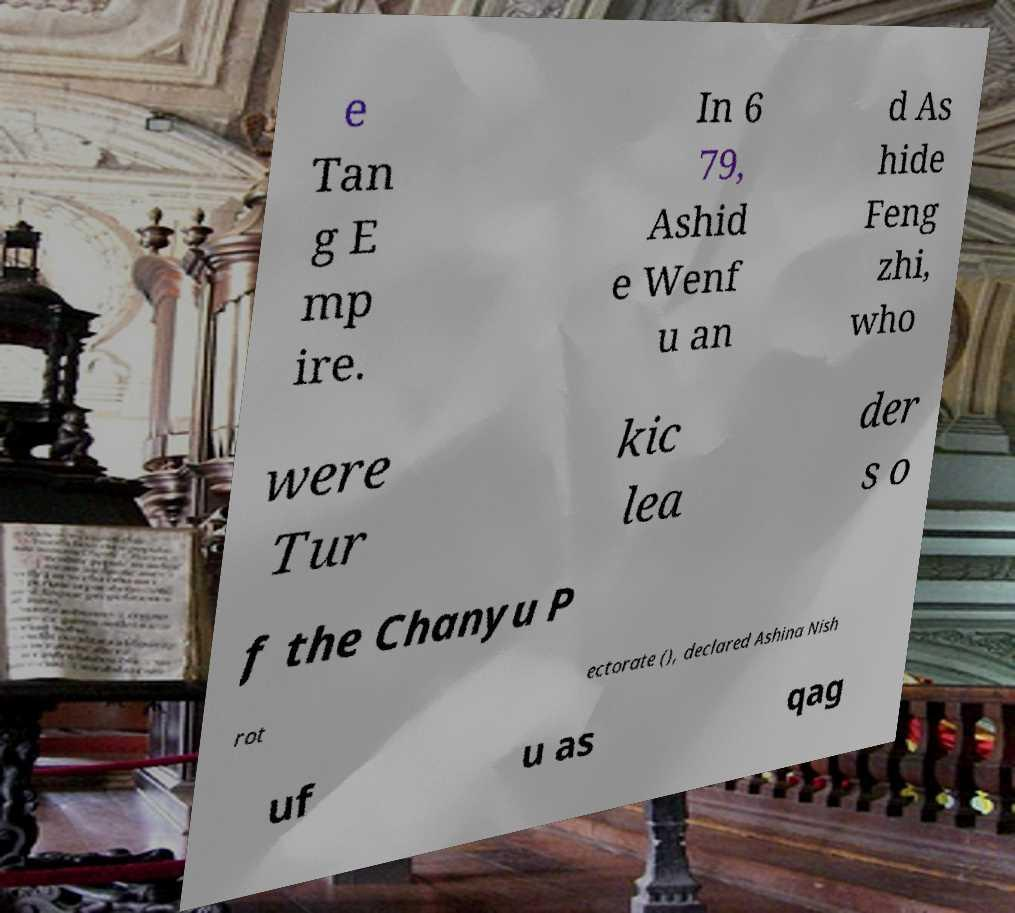There's text embedded in this image that I need extracted. Can you transcribe it verbatim? e Tan g E mp ire. In 6 79, Ashid e Wenf u an d As hide Feng zhi, who were Tur kic lea der s o f the Chanyu P rot ectorate (), declared Ashina Nish uf u as qag 